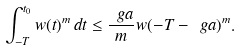<formula> <loc_0><loc_0><loc_500><loc_500>\int _ { - T } ^ { t _ { 0 } } w ( t ) ^ { m } \, d t \leq \frac { \ g a } { m } w ( - T - \ g a ) ^ { m } .</formula> 